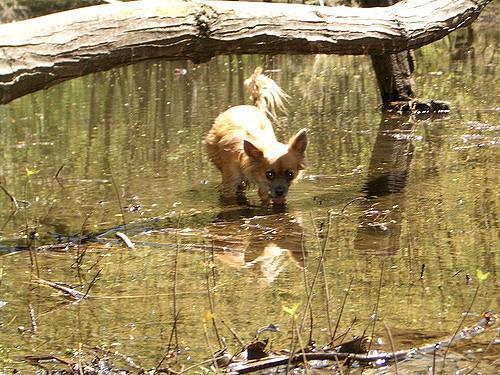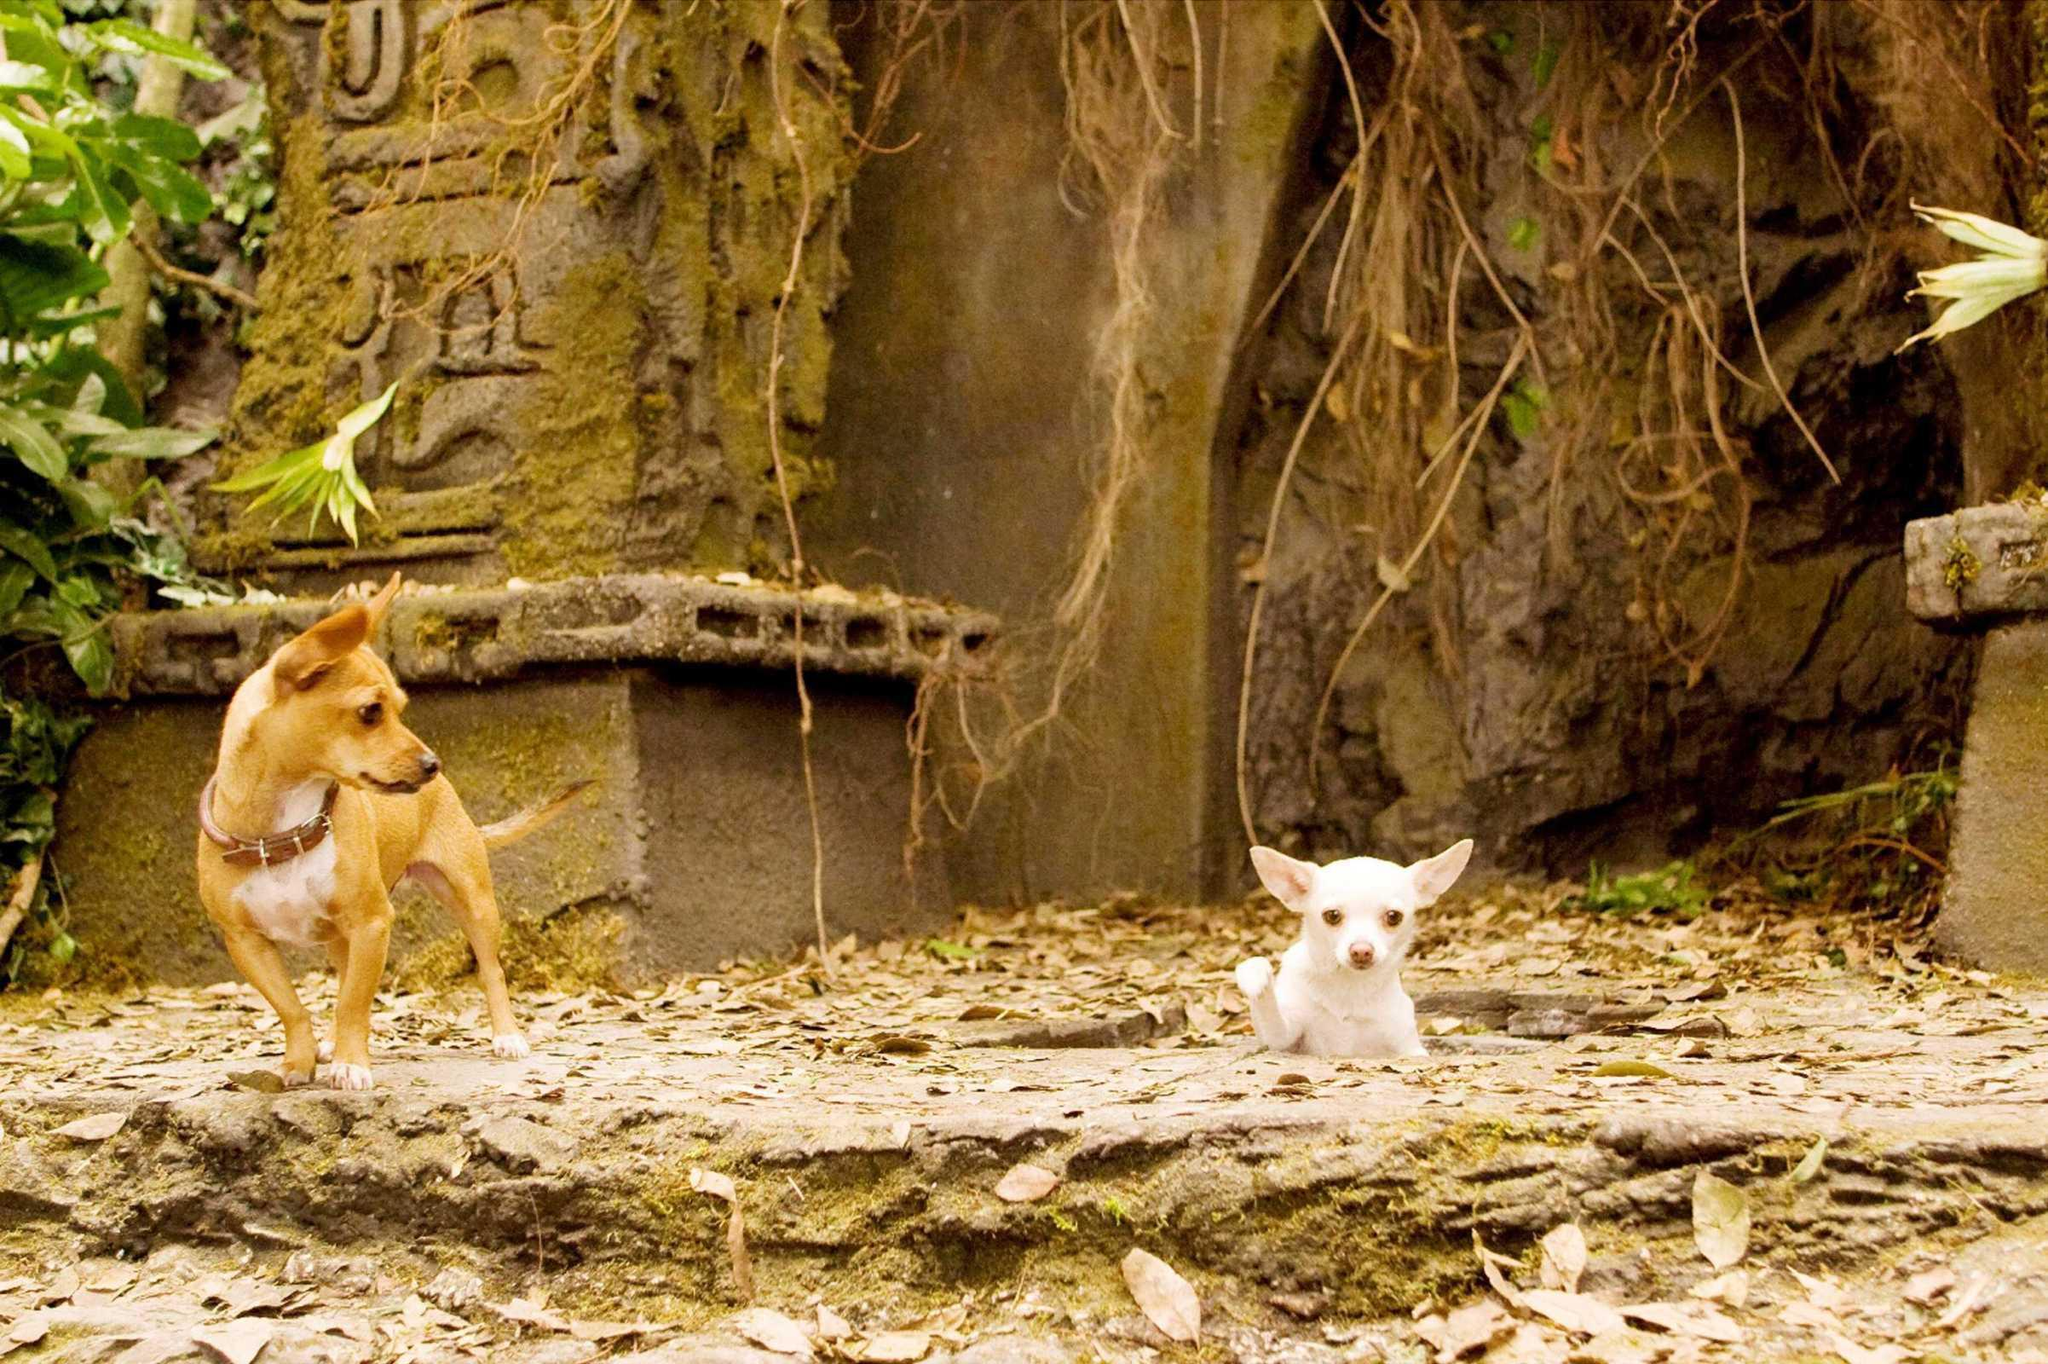The first image is the image on the left, the second image is the image on the right. Given the left and right images, does the statement "The images contain at least one row of chihuauas wearing something ornate around their necks and include at least one dog wearing a type of hat." hold true? Answer yes or no. No. The first image is the image on the left, the second image is the image on the right. Assess this claim about the two images: "One dog in the image on the right is wearing a collar.". Correct or not? Answer yes or no. Yes. 